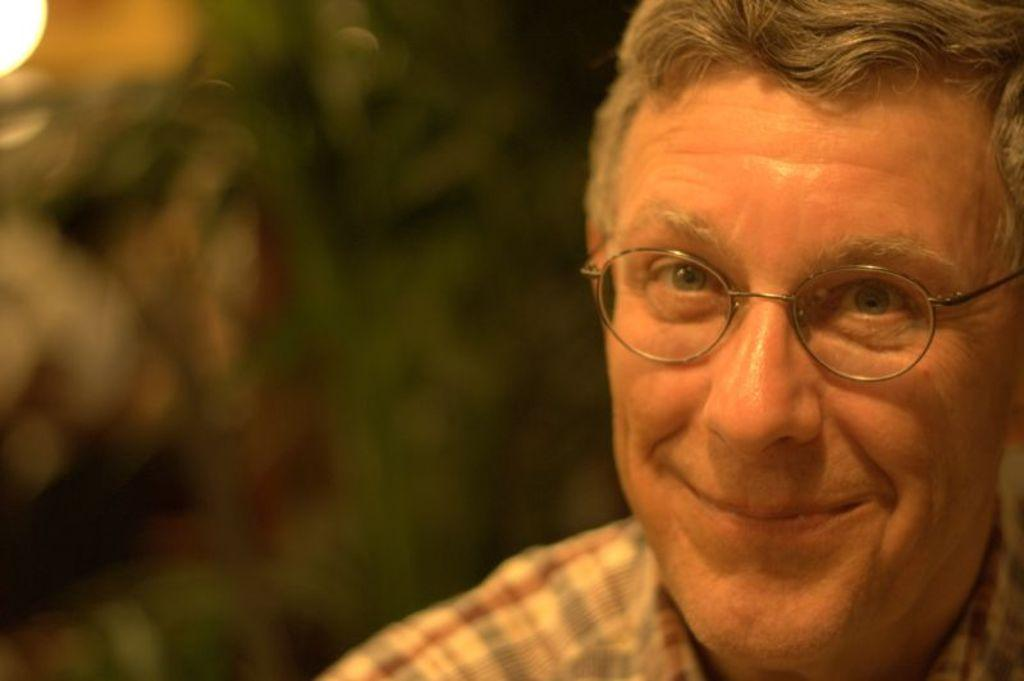Who or what is the main subject in the image? There is a person in the image. What is the person wearing? The person is wearing a dress and specs. Can you describe the background of the image? The background of the image is blurred. What type of jeans is the person wearing in the image? There is no mention of jeans in the image; the person is wearing a dress. 